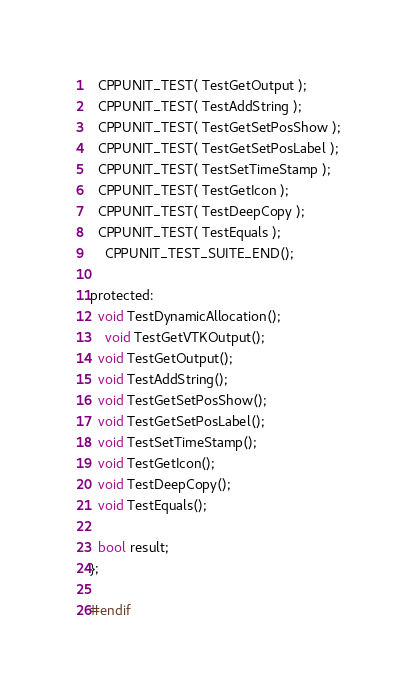Convert code to text. <code><loc_0><loc_0><loc_500><loc_500><_C_>  CPPUNIT_TEST( TestGetOutput );
  CPPUNIT_TEST( TestAddString );
  CPPUNIT_TEST( TestGetSetPosShow );
  CPPUNIT_TEST( TestGetSetPosLabel );
  CPPUNIT_TEST( TestSetTimeStamp );
  CPPUNIT_TEST( TestGetIcon );
  CPPUNIT_TEST( TestDeepCopy );
  CPPUNIT_TEST( TestEquals );
	CPPUNIT_TEST_SUITE_END();

protected:
  void TestDynamicAllocation();
	void TestGetVTKOutput();
  void TestGetOutput();
  void TestAddString();
  void TestGetSetPosShow();
  void TestGetSetPosLabel();
  void TestSetTimeStamp();
  void TestGetIcon();
  void TestDeepCopy();
  void TestEquals();

  bool result;
};

#endif
</code> 